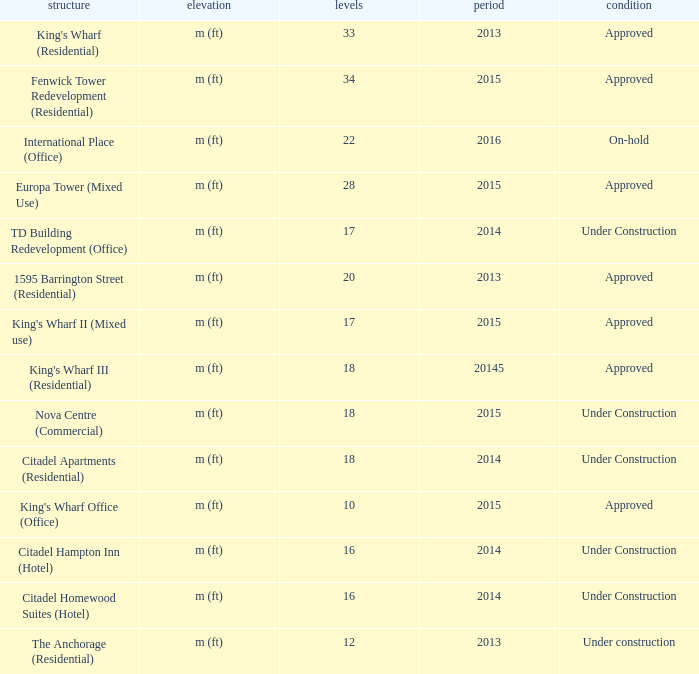What is the status of the building with more than 28 floor and a year of 2013? Approved. 